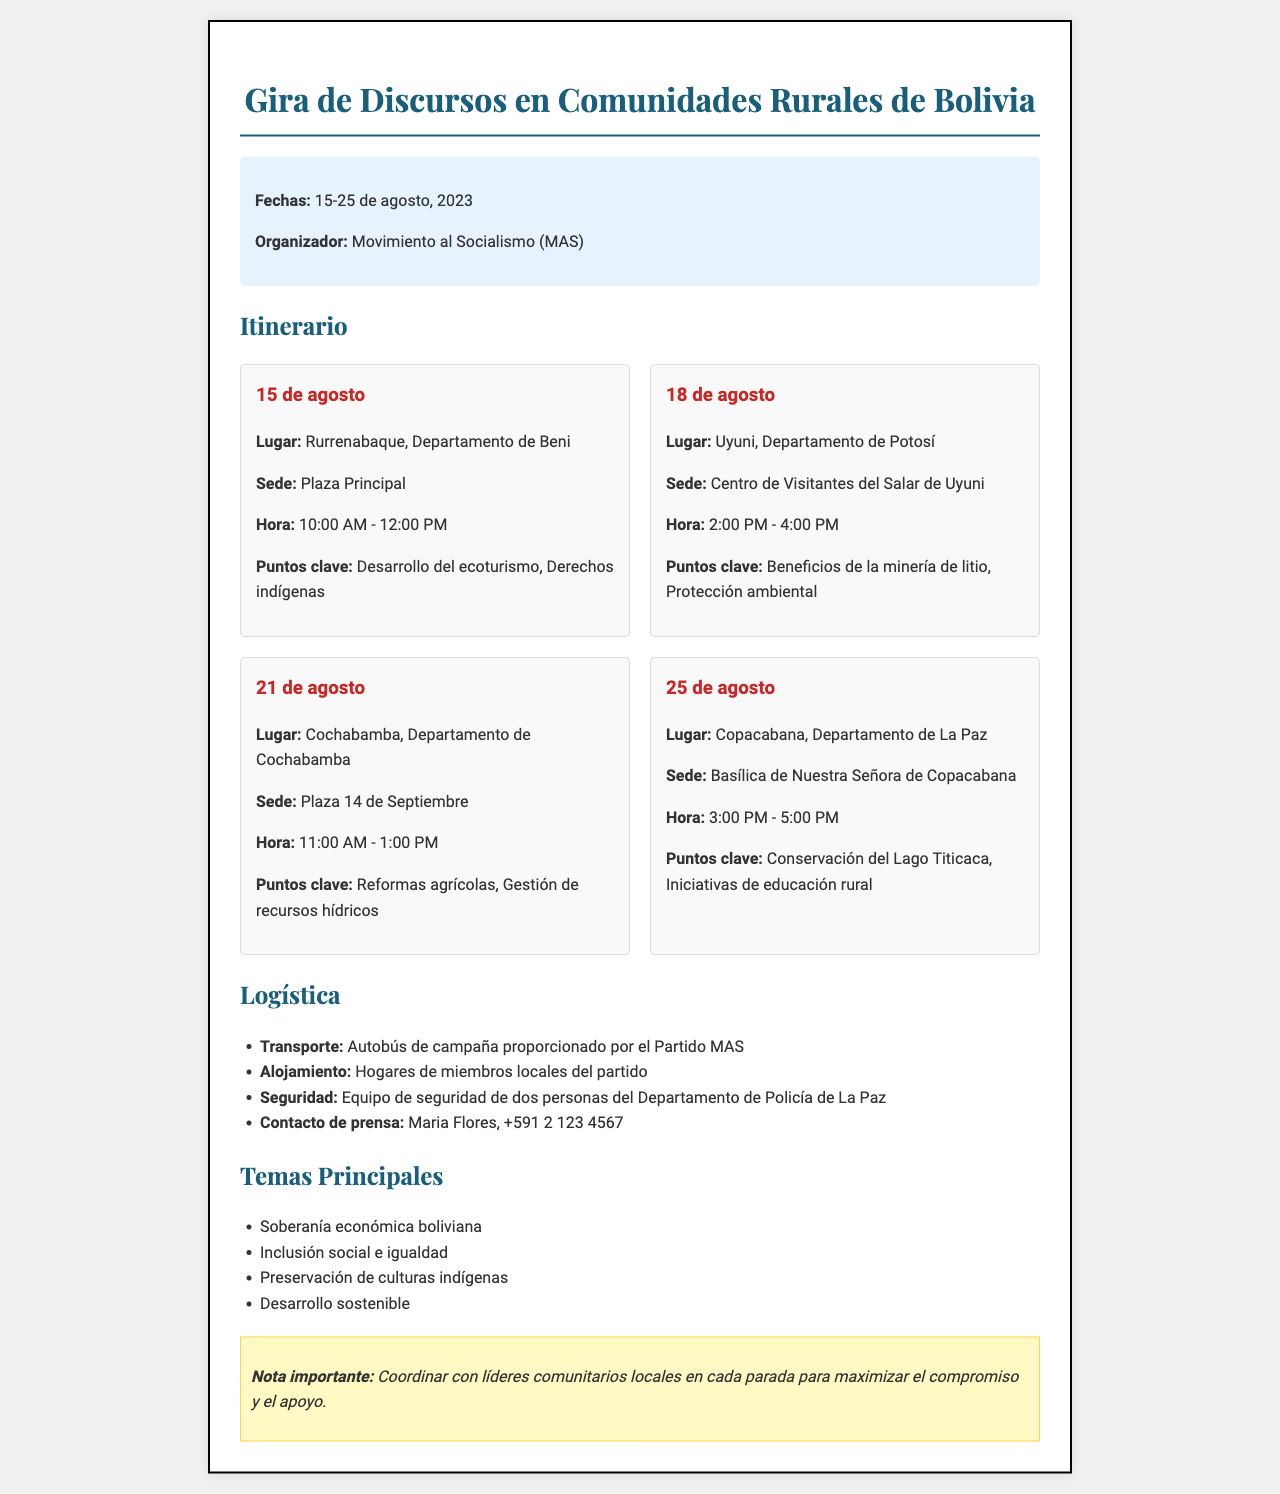What are the dates of the tour? The dates of the tour are specified in the document as 15-25 de agosto, 2023.
Answer: 15-25 de agosto, 2023 Who is the organizer? The document lists Movimiento al Socialismo (MAS) as the organizer of the tour.
Answer: Movimiento al Socialismo (MAS) What is the location of the event on August 21? The location for the event on August 21 is stated as Cochabamba, Departamento de Cochabamba.
Answer: Cochabamba, Departamento de Cochabamba What are the key points discussed at the event in Uyuni? The document specifies the key points for the Uyuni event as Beneficios de la minería de litio, Protección ambiental.
Answer: Beneficios de la minería de litio, Protección ambiental How many events are listed in the itinerary? By counting the events in the itinerary, we can see there are a total of four events.
Answer: 4 What type of transportation is provided? The transportation mentioned in the logistics section is an Autobús de campaña provided by the Partido MAS.
Answer: Autobús de campaña What is a key theme of the tour? The document lists Soberanía económica boliviana as one of the key themes.
Answer: Soberanía económica boliviana What is important to coordinate with at each stop? The fax emphasizes the importance of coordinating with líderes comunitarios locales at each stop.
Answer: Líderes comunitarios locales 